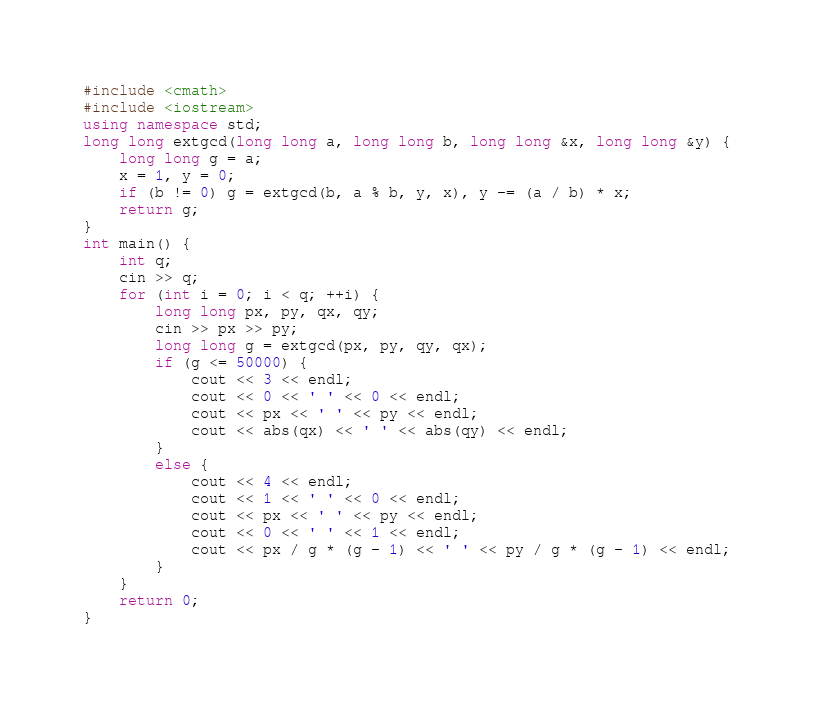Convert code to text. <code><loc_0><loc_0><loc_500><loc_500><_C++_>#include <cmath>
#include <iostream>
using namespace std;
long long extgcd(long long a, long long b, long long &x, long long &y) {
	long long g = a;
	x = 1, y = 0;
	if (b != 0) g = extgcd(b, a % b, y, x), y -= (a / b) * x;
	return g;
}
int main() {
	int q;
	cin >> q;
	for (int i = 0; i < q; ++i) {
		long long px, py, qx, qy;
		cin >> px >> py;
		long long g = extgcd(px, py, qy, qx);
		if (g <= 50000) {
			cout << 3 << endl;
			cout << 0 << ' ' << 0 << endl;
			cout << px << ' ' << py << endl;
			cout << abs(qx) << ' ' << abs(qy) << endl;
		}
		else {
			cout << 4 << endl;
			cout << 1 << ' ' << 0 << endl;
			cout << px << ' ' << py << endl;
			cout << 0 << ' ' << 1 << endl;
			cout << px / g * (g - 1) << ' ' << py / g * (g - 1) << endl;
		}
	}
	return 0;
}
</code> 